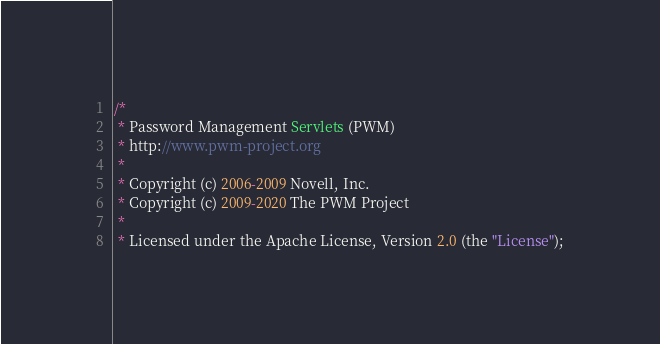<code> <loc_0><loc_0><loc_500><loc_500><_Java_>/*
 * Password Management Servlets (PWM)
 * http://www.pwm-project.org
 *
 * Copyright (c) 2006-2009 Novell, Inc.
 * Copyright (c) 2009-2020 The PWM Project
 *
 * Licensed under the Apache License, Version 2.0 (the "License");</code> 